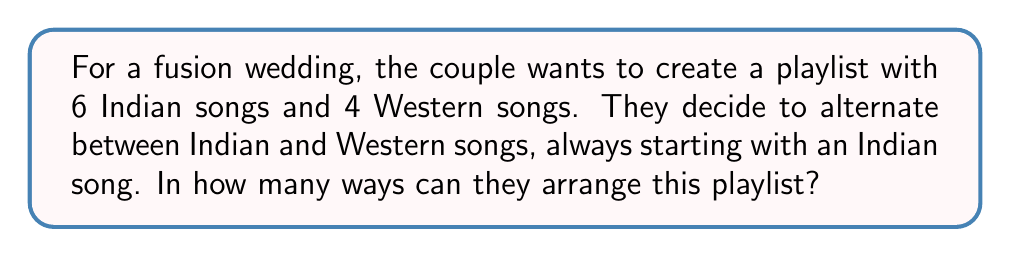Teach me how to tackle this problem. Let's approach this step-by-step:

1) The playlist will have a fixed structure of alternating Indian (I) and Western (W) songs:
   I W I W I W I W I W

2) We need to choose which Indian songs go in which Indian slots, and which Western songs go in which Western slots.

3) For the Indian songs:
   - We have 6 Indian songs to choose from for 5 slots
   - This is a permutation problem: we're arranging 5 out of 6 songs
   - The number of ways to do this is $P(6,5) = \frac{6!}{(6-5)!} = \frac{6!}{1!} = 6!$

4) For the Western songs:
   - We have 4 Western songs to fill 4 slots
   - This is a straightforward permutation of 4 items
   - The number of ways to do this is $4!$

5) By the multiplication principle, the total number of ways to arrange the playlist is:

   $$6! \times 4!$$

6) Let's calculate this:
   $$6! \times 4! = 720 \times 24 = 17,280$$

Therefore, there are 17,280 ways to arrange this playlist.
Answer: 17,280 